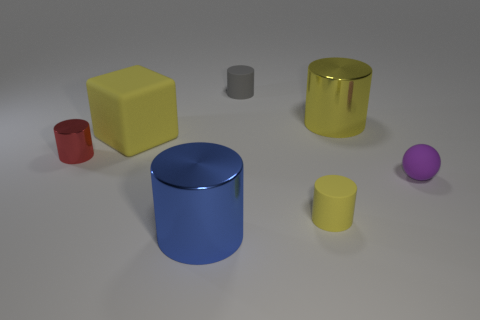Can you describe the lighting and shadows in the scene? The shadows in the image are soft and extended, suggesting a diffuse light source, likely an overhead softbox or ambient lighting in a studio setting. The objects exhibit soft-edged shadows that radiate outward, indicating the light is not very harsh. There is no strong directional light observed, as seen by the lack of sharp or high-contrast shadows. 